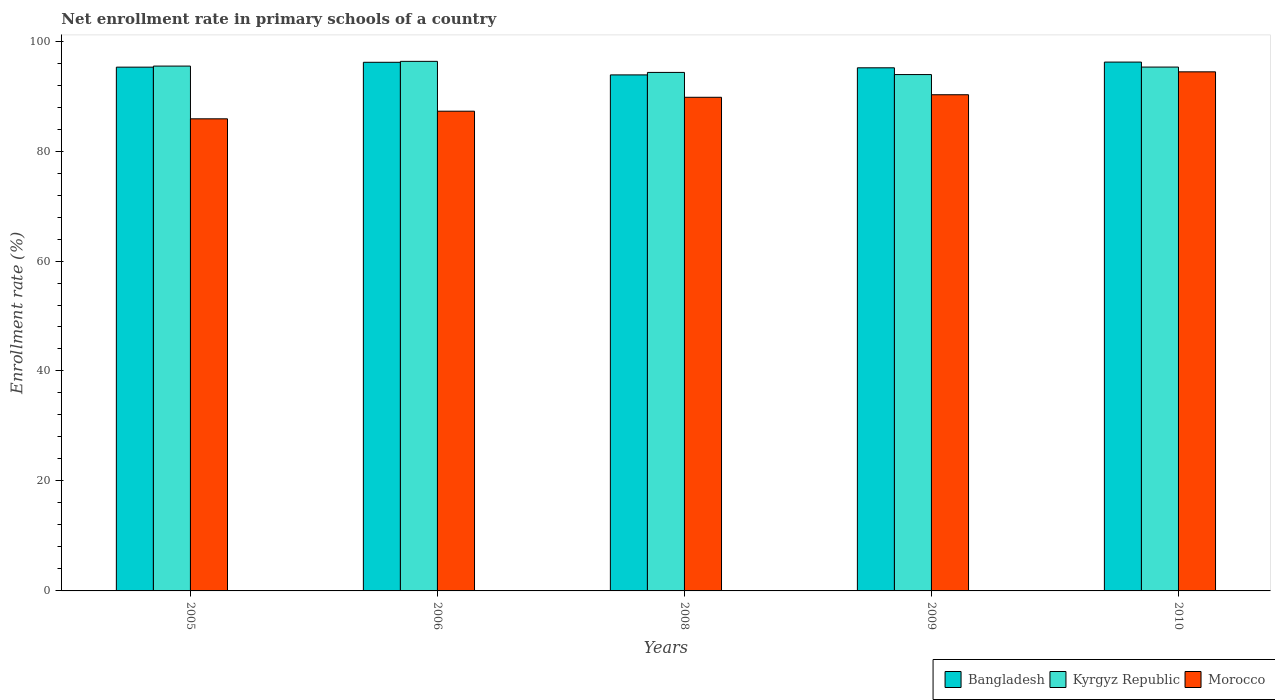What is the label of the 4th group of bars from the left?
Offer a very short reply. 2009. What is the enrollment rate in primary schools in Kyrgyz Republic in 2008?
Your answer should be compact. 94.3. Across all years, what is the maximum enrollment rate in primary schools in Bangladesh?
Provide a succinct answer. 96.18. Across all years, what is the minimum enrollment rate in primary schools in Morocco?
Provide a succinct answer. 85.86. In which year was the enrollment rate in primary schools in Kyrgyz Republic minimum?
Your response must be concise. 2009. What is the total enrollment rate in primary schools in Morocco in the graph?
Give a very brief answer. 447.53. What is the difference between the enrollment rate in primary schools in Morocco in 2006 and that in 2008?
Your answer should be very brief. -2.53. What is the difference between the enrollment rate in primary schools in Bangladesh in 2008 and the enrollment rate in primary schools in Kyrgyz Republic in 2009?
Provide a short and direct response. -0.06. What is the average enrollment rate in primary schools in Kyrgyz Republic per year?
Ensure brevity in your answer.  95.05. In the year 2005, what is the difference between the enrollment rate in primary schools in Morocco and enrollment rate in primary schools in Bangladesh?
Your answer should be compact. -9.4. What is the ratio of the enrollment rate in primary schools in Bangladesh in 2008 to that in 2010?
Provide a succinct answer. 0.98. What is the difference between the highest and the second highest enrollment rate in primary schools in Morocco?
Ensure brevity in your answer.  4.17. What is the difference between the highest and the lowest enrollment rate in primary schools in Morocco?
Make the answer very short. 8.55. What does the 3rd bar from the left in 2010 represents?
Your answer should be very brief. Morocco. What does the 1st bar from the right in 2006 represents?
Your response must be concise. Morocco. How many years are there in the graph?
Keep it short and to the point. 5. Are the values on the major ticks of Y-axis written in scientific E-notation?
Give a very brief answer. No. Does the graph contain any zero values?
Your response must be concise. No. Does the graph contain grids?
Your answer should be compact. No. Where does the legend appear in the graph?
Your response must be concise. Bottom right. How many legend labels are there?
Ensure brevity in your answer.  3. How are the legend labels stacked?
Provide a succinct answer. Horizontal. What is the title of the graph?
Offer a very short reply. Net enrollment rate in primary schools of a country. Does "Swaziland" appear as one of the legend labels in the graph?
Give a very brief answer. No. What is the label or title of the X-axis?
Your answer should be very brief. Years. What is the label or title of the Y-axis?
Offer a terse response. Enrollment rate (%). What is the Enrollment rate (%) of Bangladesh in 2005?
Make the answer very short. 95.26. What is the Enrollment rate (%) in Kyrgyz Republic in 2005?
Your response must be concise. 95.45. What is the Enrollment rate (%) of Morocco in 2005?
Make the answer very short. 85.86. What is the Enrollment rate (%) of Bangladesh in 2006?
Your response must be concise. 96.14. What is the Enrollment rate (%) of Kyrgyz Republic in 2006?
Give a very brief answer. 96.31. What is the Enrollment rate (%) in Morocco in 2006?
Offer a terse response. 87.25. What is the Enrollment rate (%) of Bangladesh in 2008?
Make the answer very short. 93.85. What is the Enrollment rate (%) in Kyrgyz Republic in 2008?
Your answer should be very brief. 94.3. What is the Enrollment rate (%) of Morocco in 2008?
Provide a succinct answer. 89.78. What is the Enrollment rate (%) of Bangladesh in 2009?
Offer a very short reply. 95.14. What is the Enrollment rate (%) in Kyrgyz Republic in 2009?
Your answer should be very brief. 93.91. What is the Enrollment rate (%) in Morocco in 2009?
Give a very brief answer. 90.24. What is the Enrollment rate (%) in Bangladesh in 2010?
Your response must be concise. 96.18. What is the Enrollment rate (%) of Kyrgyz Republic in 2010?
Keep it short and to the point. 95.27. What is the Enrollment rate (%) in Morocco in 2010?
Keep it short and to the point. 94.41. Across all years, what is the maximum Enrollment rate (%) in Bangladesh?
Ensure brevity in your answer.  96.18. Across all years, what is the maximum Enrollment rate (%) of Kyrgyz Republic?
Offer a terse response. 96.31. Across all years, what is the maximum Enrollment rate (%) in Morocco?
Make the answer very short. 94.41. Across all years, what is the minimum Enrollment rate (%) in Bangladesh?
Your answer should be very brief. 93.85. Across all years, what is the minimum Enrollment rate (%) of Kyrgyz Republic?
Provide a short and direct response. 93.91. Across all years, what is the minimum Enrollment rate (%) in Morocco?
Your answer should be very brief. 85.86. What is the total Enrollment rate (%) of Bangladesh in the graph?
Provide a succinct answer. 476.57. What is the total Enrollment rate (%) of Kyrgyz Republic in the graph?
Give a very brief answer. 475.25. What is the total Enrollment rate (%) of Morocco in the graph?
Ensure brevity in your answer.  447.53. What is the difference between the Enrollment rate (%) of Bangladesh in 2005 and that in 2006?
Provide a short and direct response. -0.89. What is the difference between the Enrollment rate (%) in Kyrgyz Republic in 2005 and that in 2006?
Keep it short and to the point. -0.86. What is the difference between the Enrollment rate (%) of Morocco in 2005 and that in 2006?
Provide a succinct answer. -1.39. What is the difference between the Enrollment rate (%) in Bangladesh in 2005 and that in 2008?
Provide a short and direct response. 1.41. What is the difference between the Enrollment rate (%) in Kyrgyz Republic in 2005 and that in 2008?
Give a very brief answer. 1.15. What is the difference between the Enrollment rate (%) of Morocco in 2005 and that in 2008?
Your response must be concise. -3.92. What is the difference between the Enrollment rate (%) of Bangladesh in 2005 and that in 2009?
Make the answer very short. 0.12. What is the difference between the Enrollment rate (%) of Kyrgyz Republic in 2005 and that in 2009?
Your answer should be compact. 1.54. What is the difference between the Enrollment rate (%) in Morocco in 2005 and that in 2009?
Ensure brevity in your answer.  -4.38. What is the difference between the Enrollment rate (%) in Bangladesh in 2005 and that in 2010?
Provide a succinct answer. -0.92. What is the difference between the Enrollment rate (%) of Kyrgyz Republic in 2005 and that in 2010?
Offer a terse response. 0.18. What is the difference between the Enrollment rate (%) of Morocco in 2005 and that in 2010?
Offer a terse response. -8.55. What is the difference between the Enrollment rate (%) in Bangladesh in 2006 and that in 2008?
Make the answer very short. 2.29. What is the difference between the Enrollment rate (%) in Kyrgyz Republic in 2006 and that in 2008?
Your answer should be very brief. 2.01. What is the difference between the Enrollment rate (%) of Morocco in 2006 and that in 2008?
Make the answer very short. -2.53. What is the difference between the Enrollment rate (%) of Kyrgyz Republic in 2006 and that in 2009?
Make the answer very short. 2.4. What is the difference between the Enrollment rate (%) in Morocco in 2006 and that in 2009?
Offer a very short reply. -2.99. What is the difference between the Enrollment rate (%) in Bangladesh in 2006 and that in 2010?
Provide a succinct answer. -0.04. What is the difference between the Enrollment rate (%) in Kyrgyz Republic in 2006 and that in 2010?
Offer a very short reply. 1.04. What is the difference between the Enrollment rate (%) in Morocco in 2006 and that in 2010?
Make the answer very short. -7.16. What is the difference between the Enrollment rate (%) of Bangladesh in 2008 and that in 2009?
Offer a very short reply. -1.29. What is the difference between the Enrollment rate (%) in Kyrgyz Republic in 2008 and that in 2009?
Provide a succinct answer. 0.39. What is the difference between the Enrollment rate (%) of Morocco in 2008 and that in 2009?
Your response must be concise. -0.47. What is the difference between the Enrollment rate (%) of Bangladesh in 2008 and that in 2010?
Your response must be concise. -2.33. What is the difference between the Enrollment rate (%) in Kyrgyz Republic in 2008 and that in 2010?
Keep it short and to the point. -0.97. What is the difference between the Enrollment rate (%) in Morocco in 2008 and that in 2010?
Your response must be concise. -4.63. What is the difference between the Enrollment rate (%) of Bangladesh in 2009 and that in 2010?
Ensure brevity in your answer.  -1.04. What is the difference between the Enrollment rate (%) of Kyrgyz Republic in 2009 and that in 2010?
Offer a very short reply. -1.36. What is the difference between the Enrollment rate (%) in Morocco in 2009 and that in 2010?
Offer a terse response. -4.17. What is the difference between the Enrollment rate (%) of Bangladesh in 2005 and the Enrollment rate (%) of Kyrgyz Republic in 2006?
Give a very brief answer. -1.05. What is the difference between the Enrollment rate (%) in Bangladesh in 2005 and the Enrollment rate (%) in Morocco in 2006?
Your response must be concise. 8.01. What is the difference between the Enrollment rate (%) of Kyrgyz Republic in 2005 and the Enrollment rate (%) of Morocco in 2006?
Keep it short and to the point. 8.2. What is the difference between the Enrollment rate (%) in Bangladesh in 2005 and the Enrollment rate (%) in Kyrgyz Republic in 2008?
Provide a short and direct response. 0.96. What is the difference between the Enrollment rate (%) of Bangladesh in 2005 and the Enrollment rate (%) of Morocco in 2008?
Offer a terse response. 5.48. What is the difference between the Enrollment rate (%) in Kyrgyz Republic in 2005 and the Enrollment rate (%) in Morocco in 2008?
Ensure brevity in your answer.  5.68. What is the difference between the Enrollment rate (%) in Bangladesh in 2005 and the Enrollment rate (%) in Kyrgyz Republic in 2009?
Offer a very short reply. 1.35. What is the difference between the Enrollment rate (%) in Bangladesh in 2005 and the Enrollment rate (%) in Morocco in 2009?
Ensure brevity in your answer.  5.02. What is the difference between the Enrollment rate (%) in Kyrgyz Republic in 2005 and the Enrollment rate (%) in Morocco in 2009?
Your answer should be compact. 5.21. What is the difference between the Enrollment rate (%) in Bangladesh in 2005 and the Enrollment rate (%) in Kyrgyz Republic in 2010?
Your response must be concise. -0.01. What is the difference between the Enrollment rate (%) in Bangladesh in 2005 and the Enrollment rate (%) in Morocco in 2010?
Ensure brevity in your answer.  0.85. What is the difference between the Enrollment rate (%) of Kyrgyz Republic in 2005 and the Enrollment rate (%) of Morocco in 2010?
Make the answer very short. 1.04. What is the difference between the Enrollment rate (%) in Bangladesh in 2006 and the Enrollment rate (%) in Kyrgyz Republic in 2008?
Offer a terse response. 1.84. What is the difference between the Enrollment rate (%) of Bangladesh in 2006 and the Enrollment rate (%) of Morocco in 2008?
Keep it short and to the point. 6.37. What is the difference between the Enrollment rate (%) in Kyrgyz Republic in 2006 and the Enrollment rate (%) in Morocco in 2008?
Provide a succinct answer. 6.54. What is the difference between the Enrollment rate (%) in Bangladesh in 2006 and the Enrollment rate (%) in Kyrgyz Republic in 2009?
Your response must be concise. 2.23. What is the difference between the Enrollment rate (%) of Bangladesh in 2006 and the Enrollment rate (%) of Morocco in 2009?
Ensure brevity in your answer.  5.9. What is the difference between the Enrollment rate (%) in Kyrgyz Republic in 2006 and the Enrollment rate (%) in Morocco in 2009?
Keep it short and to the point. 6.07. What is the difference between the Enrollment rate (%) of Bangladesh in 2006 and the Enrollment rate (%) of Kyrgyz Republic in 2010?
Make the answer very short. 0.87. What is the difference between the Enrollment rate (%) of Bangladesh in 2006 and the Enrollment rate (%) of Morocco in 2010?
Your answer should be compact. 1.74. What is the difference between the Enrollment rate (%) of Kyrgyz Republic in 2006 and the Enrollment rate (%) of Morocco in 2010?
Offer a very short reply. 1.91. What is the difference between the Enrollment rate (%) in Bangladesh in 2008 and the Enrollment rate (%) in Kyrgyz Republic in 2009?
Make the answer very short. -0.06. What is the difference between the Enrollment rate (%) of Bangladesh in 2008 and the Enrollment rate (%) of Morocco in 2009?
Offer a terse response. 3.61. What is the difference between the Enrollment rate (%) of Kyrgyz Republic in 2008 and the Enrollment rate (%) of Morocco in 2009?
Ensure brevity in your answer.  4.06. What is the difference between the Enrollment rate (%) in Bangladesh in 2008 and the Enrollment rate (%) in Kyrgyz Republic in 2010?
Provide a short and direct response. -1.42. What is the difference between the Enrollment rate (%) of Bangladesh in 2008 and the Enrollment rate (%) of Morocco in 2010?
Ensure brevity in your answer.  -0.56. What is the difference between the Enrollment rate (%) of Kyrgyz Republic in 2008 and the Enrollment rate (%) of Morocco in 2010?
Provide a succinct answer. -0.1. What is the difference between the Enrollment rate (%) in Bangladesh in 2009 and the Enrollment rate (%) in Kyrgyz Republic in 2010?
Provide a short and direct response. -0.13. What is the difference between the Enrollment rate (%) in Bangladesh in 2009 and the Enrollment rate (%) in Morocco in 2010?
Give a very brief answer. 0.73. What is the difference between the Enrollment rate (%) in Kyrgyz Republic in 2009 and the Enrollment rate (%) in Morocco in 2010?
Offer a terse response. -0.5. What is the average Enrollment rate (%) of Bangladesh per year?
Ensure brevity in your answer.  95.31. What is the average Enrollment rate (%) in Kyrgyz Republic per year?
Your answer should be compact. 95.05. What is the average Enrollment rate (%) in Morocco per year?
Keep it short and to the point. 89.51. In the year 2005, what is the difference between the Enrollment rate (%) of Bangladesh and Enrollment rate (%) of Kyrgyz Republic?
Offer a very short reply. -0.19. In the year 2005, what is the difference between the Enrollment rate (%) in Bangladesh and Enrollment rate (%) in Morocco?
Provide a succinct answer. 9.4. In the year 2005, what is the difference between the Enrollment rate (%) in Kyrgyz Republic and Enrollment rate (%) in Morocco?
Your response must be concise. 9.59. In the year 2006, what is the difference between the Enrollment rate (%) in Bangladesh and Enrollment rate (%) in Kyrgyz Republic?
Provide a short and direct response. -0.17. In the year 2006, what is the difference between the Enrollment rate (%) in Bangladesh and Enrollment rate (%) in Morocco?
Make the answer very short. 8.89. In the year 2006, what is the difference between the Enrollment rate (%) in Kyrgyz Republic and Enrollment rate (%) in Morocco?
Provide a succinct answer. 9.06. In the year 2008, what is the difference between the Enrollment rate (%) in Bangladesh and Enrollment rate (%) in Kyrgyz Republic?
Your response must be concise. -0.45. In the year 2008, what is the difference between the Enrollment rate (%) in Bangladesh and Enrollment rate (%) in Morocco?
Your answer should be compact. 4.07. In the year 2008, what is the difference between the Enrollment rate (%) of Kyrgyz Republic and Enrollment rate (%) of Morocco?
Offer a very short reply. 4.53. In the year 2009, what is the difference between the Enrollment rate (%) of Bangladesh and Enrollment rate (%) of Kyrgyz Republic?
Your response must be concise. 1.23. In the year 2009, what is the difference between the Enrollment rate (%) of Bangladesh and Enrollment rate (%) of Morocco?
Provide a succinct answer. 4.9. In the year 2009, what is the difference between the Enrollment rate (%) of Kyrgyz Republic and Enrollment rate (%) of Morocco?
Your answer should be very brief. 3.67. In the year 2010, what is the difference between the Enrollment rate (%) of Bangladesh and Enrollment rate (%) of Kyrgyz Republic?
Make the answer very short. 0.91. In the year 2010, what is the difference between the Enrollment rate (%) of Bangladesh and Enrollment rate (%) of Morocco?
Your answer should be compact. 1.77. In the year 2010, what is the difference between the Enrollment rate (%) of Kyrgyz Republic and Enrollment rate (%) of Morocco?
Provide a short and direct response. 0.87. What is the ratio of the Enrollment rate (%) of Morocco in 2005 to that in 2006?
Your response must be concise. 0.98. What is the ratio of the Enrollment rate (%) of Bangladesh in 2005 to that in 2008?
Offer a terse response. 1.01. What is the ratio of the Enrollment rate (%) in Kyrgyz Republic in 2005 to that in 2008?
Your response must be concise. 1.01. What is the ratio of the Enrollment rate (%) of Morocco in 2005 to that in 2008?
Provide a succinct answer. 0.96. What is the ratio of the Enrollment rate (%) in Kyrgyz Republic in 2005 to that in 2009?
Your answer should be compact. 1.02. What is the ratio of the Enrollment rate (%) of Morocco in 2005 to that in 2009?
Offer a terse response. 0.95. What is the ratio of the Enrollment rate (%) in Bangladesh in 2005 to that in 2010?
Your answer should be very brief. 0.99. What is the ratio of the Enrollment rate (%) in Morocco in 2005 to that in 2010?
Your response must be concise. 0.91. What is the ratio of the Enrollment rate (%) in Bangladesh in 2006 to that in 2008?
Offer a very short reply. 1.02. What is the ratio of the Enrollment rate (%) in Kyrgyz Republic in 2006 to that in 2008?
Ensure brevity in your answer.  1.02. What is the ratio of the Enrollment rate (%) in Morocco in 2006 to that in 2008?
Give a very brief answer. 0.97. What is the ratio of the Enrollment rate (%) in Bangladesh in 2006 to that in 2009?
Your answer should be compact. 1.01. What is the ratio of the Enrollment rate (%) of Kyrgyz Republic in 2006 to that in 2009?
Your answer should be compact. 1.03. What is the ratio of the Enrollment rate (%) of Morocco in 2006 to that in 2009?
Your answer should be compact. 0.97. What is the ratio of the Enrollment rate (%) in Bangladesh in 2006 to that in 2010?
Provide a short and direct response. 1. What is the ratio of the Enrollment rate (%) of Kyrgyz Republic in 2006 to that in 2010?
Provide a short and direct response. 1.01. What is the ratio of the Enrollment rate (%) in Morocco in 2006 to that in 2010?
Keep it short and to the point. 0.92. What is the ratio of the Enrollment rate (%) in Bangladesh in 2008 to that in 2009?
Make the answer very short. 0.99. What is the ratio of the Enrollment rate (%) of Bangladesh in 2008 to that in 2010?
Make the answer very short. 0.98. What is the ratio of the Enrollment rate (%) in Kyrgyz Republic in 2008 to that in 2010?
Your answer should be compact. 0.99. What is the ratio of the Enrollment rate (%) of Morocco in 2008 to that in 2010?
Give a very brief answer. 0.95. What is the ratio of the Enrollment rate (%) in Bangladesh in 2009 to that in 2010?
Keep it short and to the point. 0.99. What is the ratio of the Enrollment rate (%) of Kyrgyz Republic in 2009 to that in 2010?
Make the answer very short. 0.99. What is the ratio of the Enrollment rate (%) of Morocco in 2009 to that in 2010?
Make the answer very short. 0.96. What is the difference between the highest and the second highest Enrollment rate (%) in Bangladesh?
Provide a short and direct response. 0.04. What is the difference between the highest and the second highest Enrollment rate (%) of Kyrgyz Republic?
Offer a terse response. 0.86. What is the difference between the highest and the second highest Enrollment rate (%) of Morocco?
Offer a terse response. 4.17. What is the difference between the highest and the lowest Enrollment rate (%) in Bangladesh?
Ensure brevity in your answer.  2.33. What is the difference between the highest and the lowest Enrollment rate (%) in Kyrgyz Republic?
Your answer should be very brief. 2.4. What is the difference between the highest and the lowest Enrollment rate (%) in Morocco?
Make the answer very short. 8.55. 